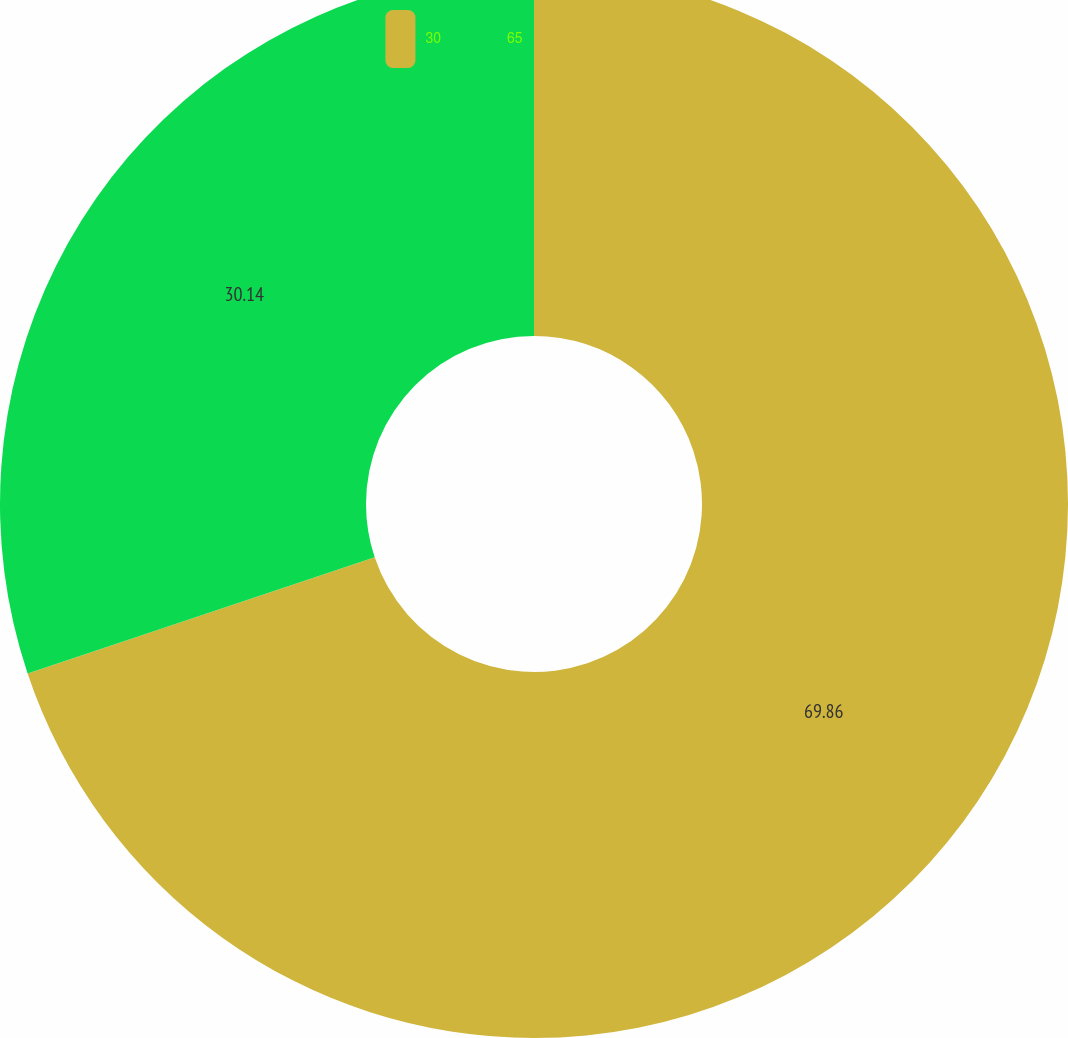Convert chart to OTSL. <chart><loc_0><loc_0><loc_500><loc_500><pie_chart><fcel>30<fcel>65<nl><fcel>69.86%<fcel>30.14%<nl></chart> 